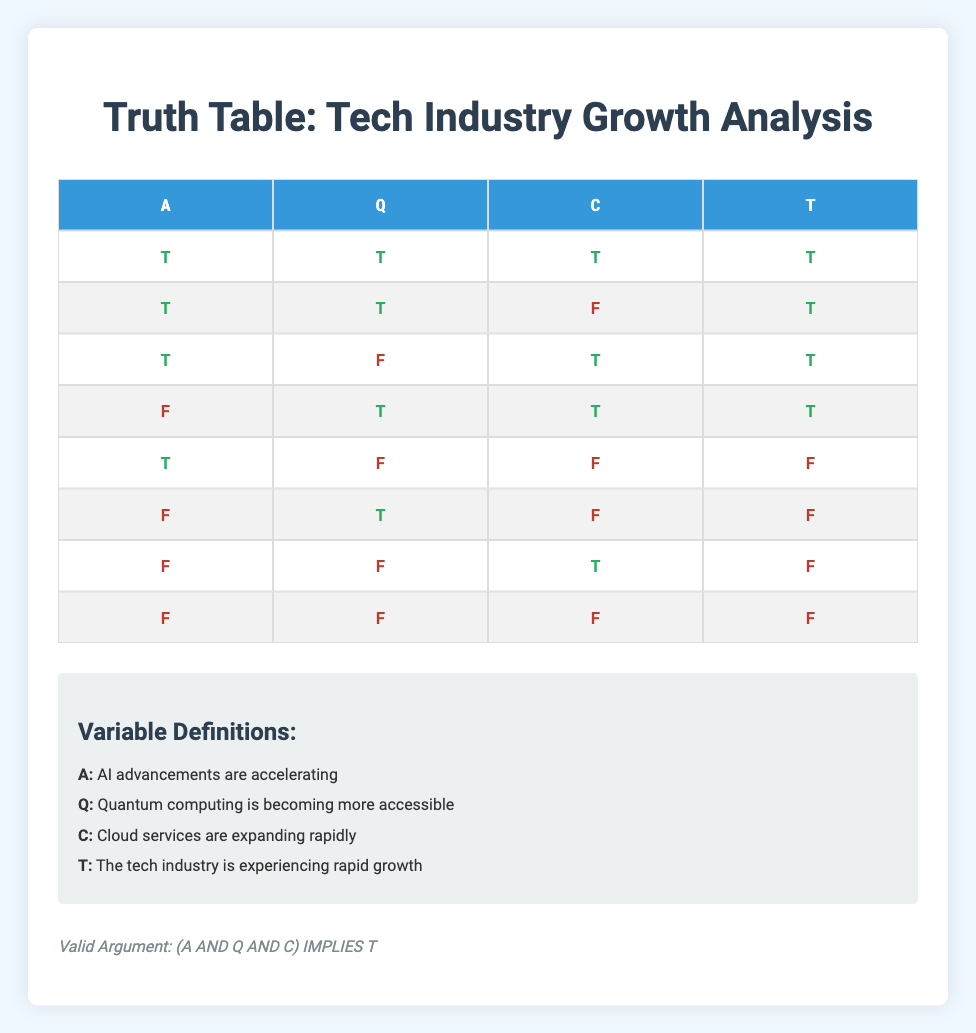What is the truth value for A, Q, C, and T when all premises are true? The first row of the truth table indicates that when A (AI advancements), Q (Quantum computing), and C (Cloud services) are all true, T (Tech industry growth) is also true.
Answer: All true Are there any scenarios where AI advancements are true, Quantum computing is true, but Cloud services are false? Looking at the table, the second row shows that when A and Q are true, but C is false, T remains true. This confirms that such a scenario exists.
Answer: Yes How many combinations lead to a true conclusion (T)? In the truth table, we can see that there are four occurrences of T in the conclusion column across all rows. This is found by counting the number of rows where T is true.
Answer: Four Is it valid to conclude the tech industry is experiencing rapid growth if AI advancements are false? Based on the table, in rows 5, 6, and 7 when A is false, T is also false in all those instances. Therefore, it cannot be valid to conclude T when A is false.
Answer: No What percentage of the scenarios show that both Quantum computing and Cloud services must be true for the tech industry growth to be true? The truth table has a total of 8 rows. Looking at the rows where T is true, rows 1, 2, 3, and 4 show that both Q and C must be true (though C can be a mix in row 4). Calculating the percentage: 4 (rows with T true) / 8 (total rows) * 100 = 50%.
Answer: 50% In how many cases is at least one premise true but the conclusion is false? Checking the rows where T is false, we find rows 5, 6, and 7. In all these cases, at least one (or more) premises are true, yet the conclusion is false, leading to a total of three cases.
Answer: Three If all premises are false, what is the truth value of the conclusion? The last row of the truth table indicates that when A, Q, and C are all false, T is also false. Therefore, the conclusion remains false when all premises are false.
Answer: False Which premise combinations ensure that the conclusion is always true? The only combination that guarantees a true conclusion is when A, Q, and C are all true, which corresponds to the first row. This can also be seen in the second and fourth rows where T remains true despite variations in C. However, the essential condition for T to be valid is all premises being true.
Answer: A, Q, C all true 